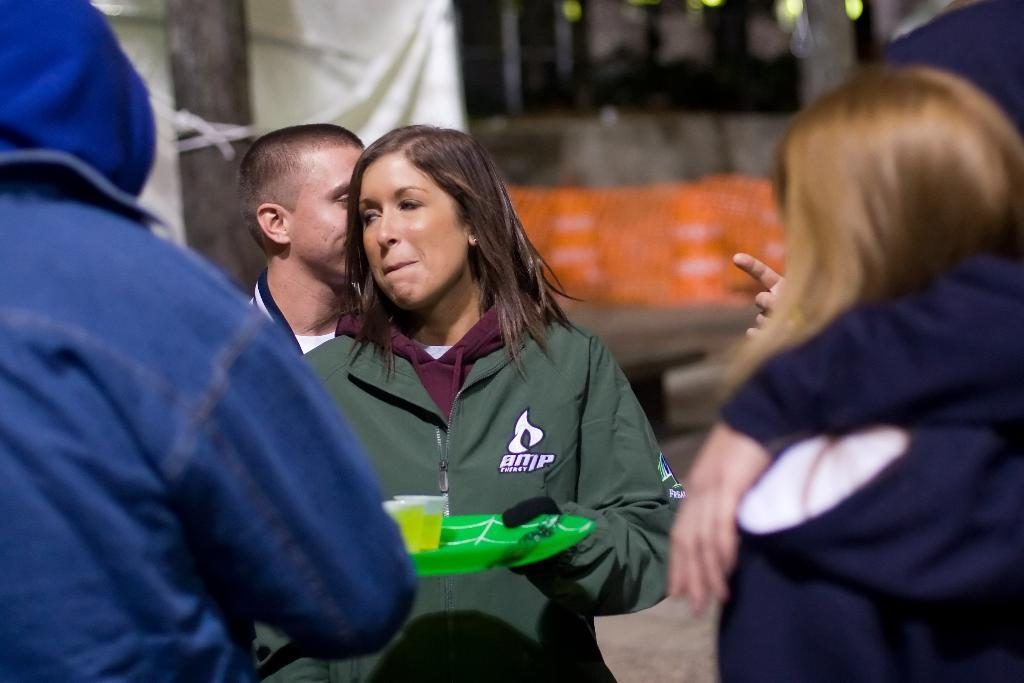How many people are in the image? There is a group of people in the image. Can you describe the clothing of one of the individuals? One person is wearing a green jacket. What is the person in the green jacket holding? The person in the green jacket is holding a plate. What can be observed about the background of the image? The background of the image is blurred. What type of popcorn is being served on the plate held by the person in the green jacket? There is no popcorn present in the image. 